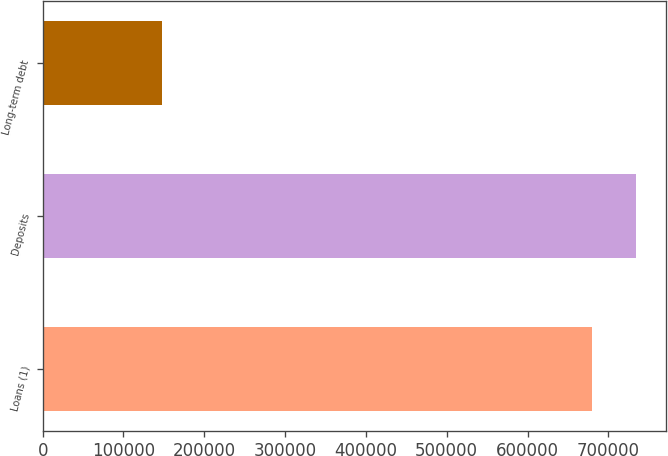Convert chart to OTSL. <chart><loc_0><loc_0><loc_500><loc_500><bar_chart><fcel>Loans (1)<fcel>Deposits<fcel>Long-term debt<nl><fcel>679738<fcel>734230<fcel>148120<nl></chart> 